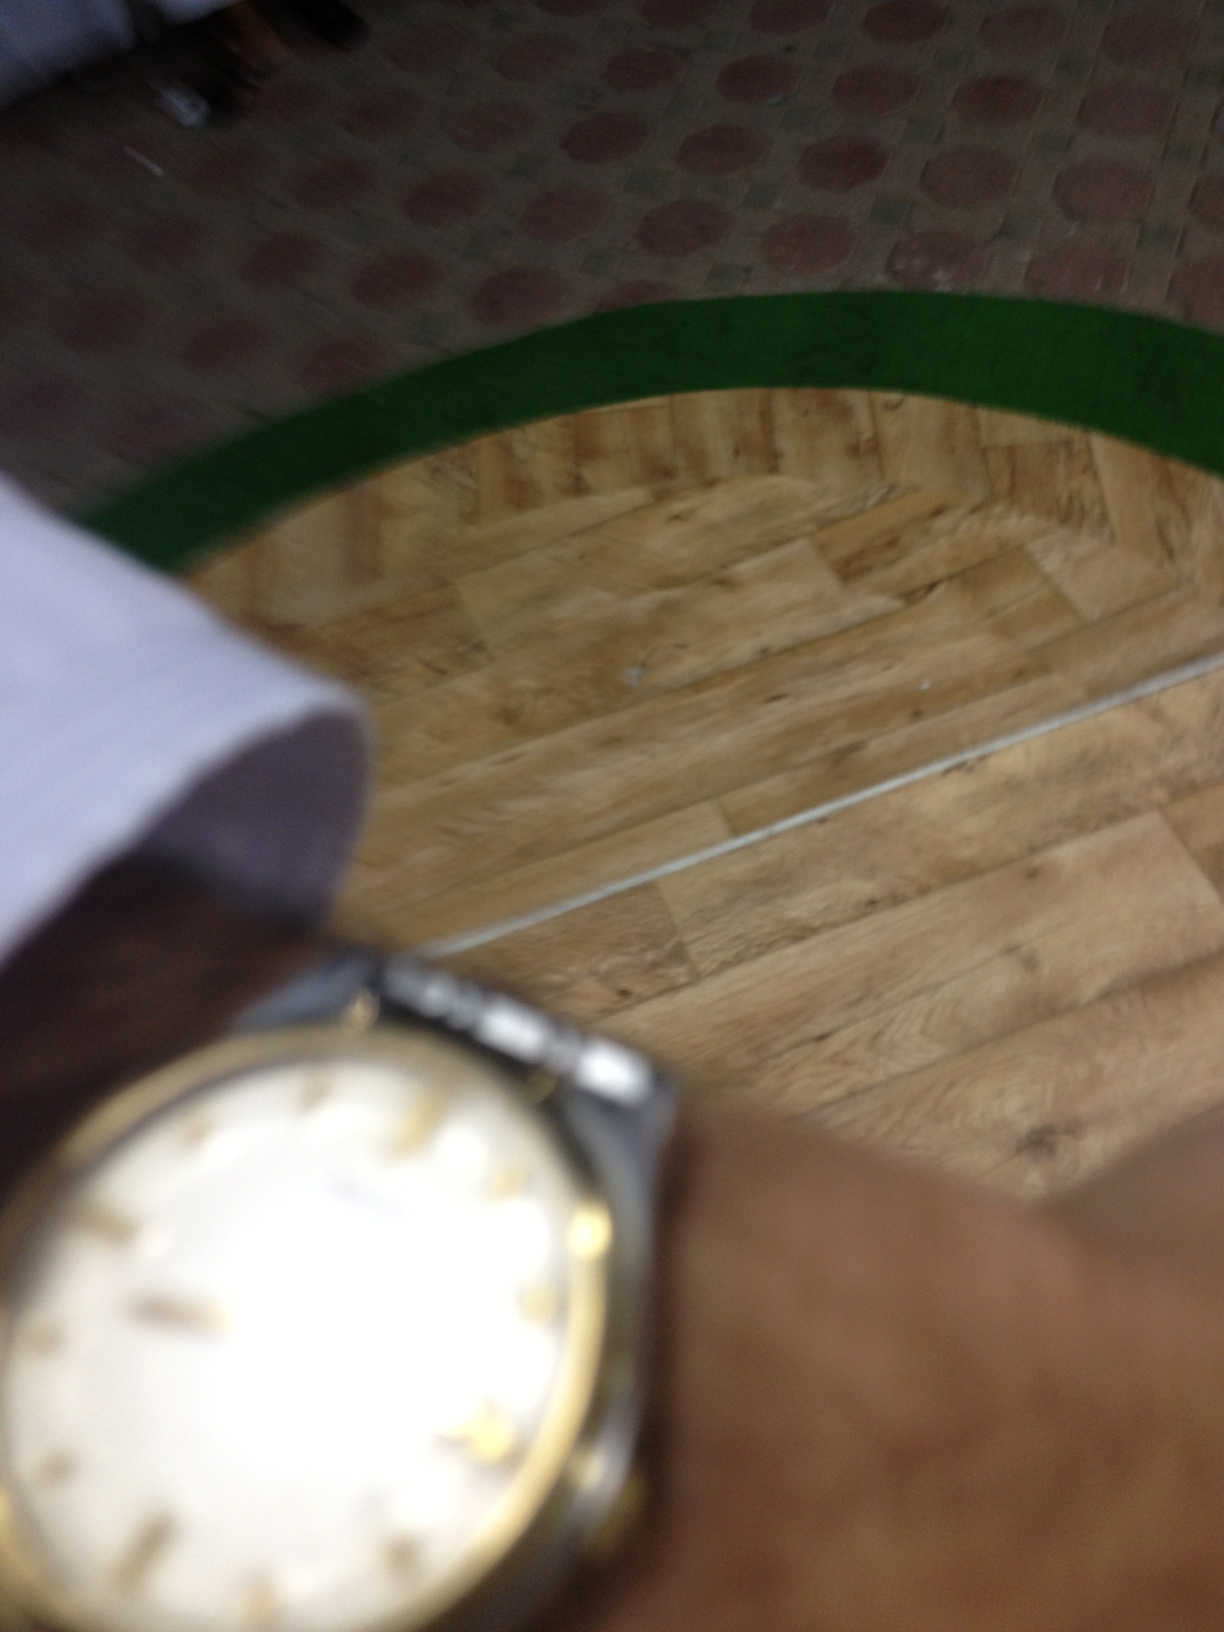Can you tell more about the watch's style and any visible features? The watch in the image sports a classic design with a gold-toned bezel and a dark leather strap. The dial is adorned with Roman numerals which add to its elegant look. Due to the quality of the image, specific details like brand or functionality aspects cannot be discerned clearly. 